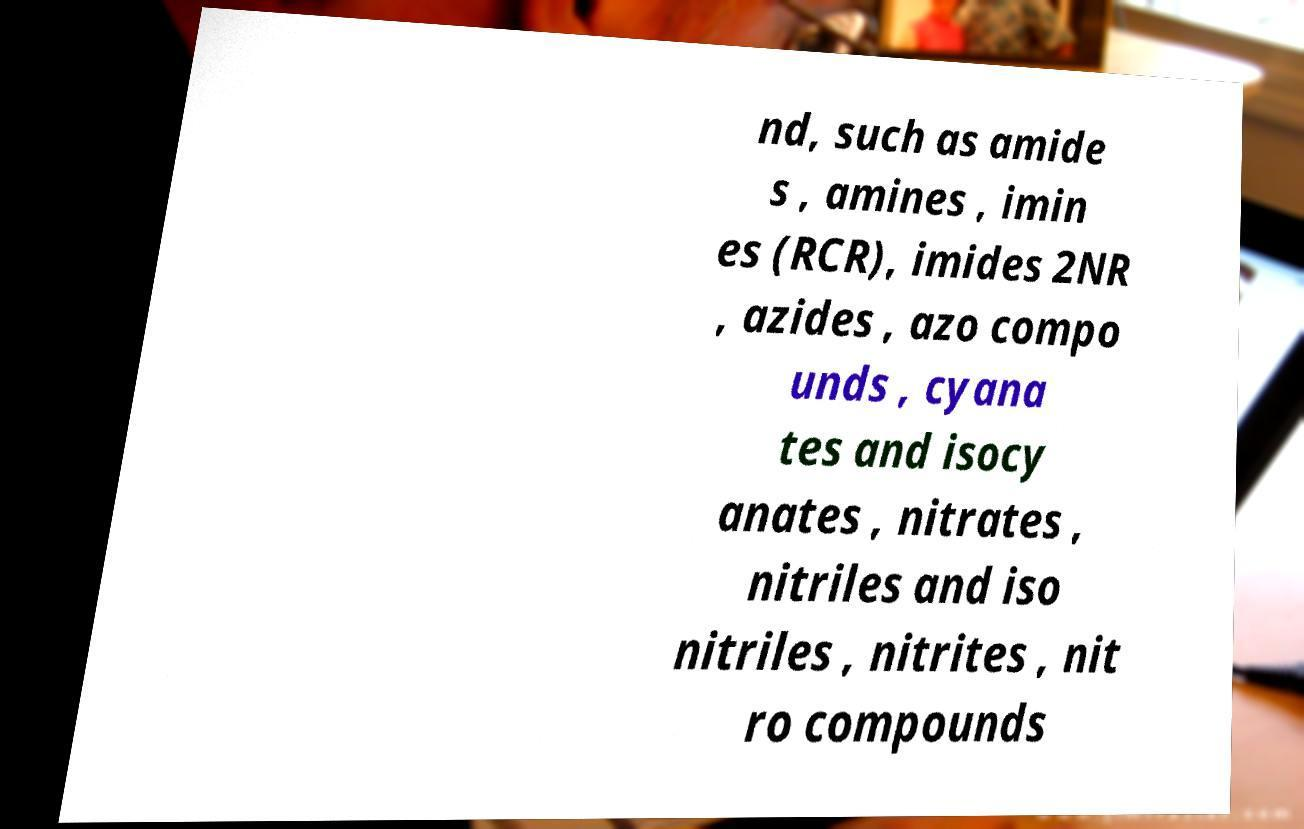I need the written content from this picture converted into text. Can you do that? nd, such as amide s , amines , imin es (RCR), imides 2NR , azides , azo compo unds , cyana tes and isocy anates , nitrates , nitriles and iso nitriles , nitrites , nit ro compounds 